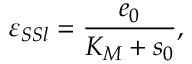<formula> <loc_0><loc_0><loc_500><loc_500>\varepsilon _ { S S l } = \frac { e _ { 0 } } { K _ { M } + s _ { 0 } } ,</formula> 